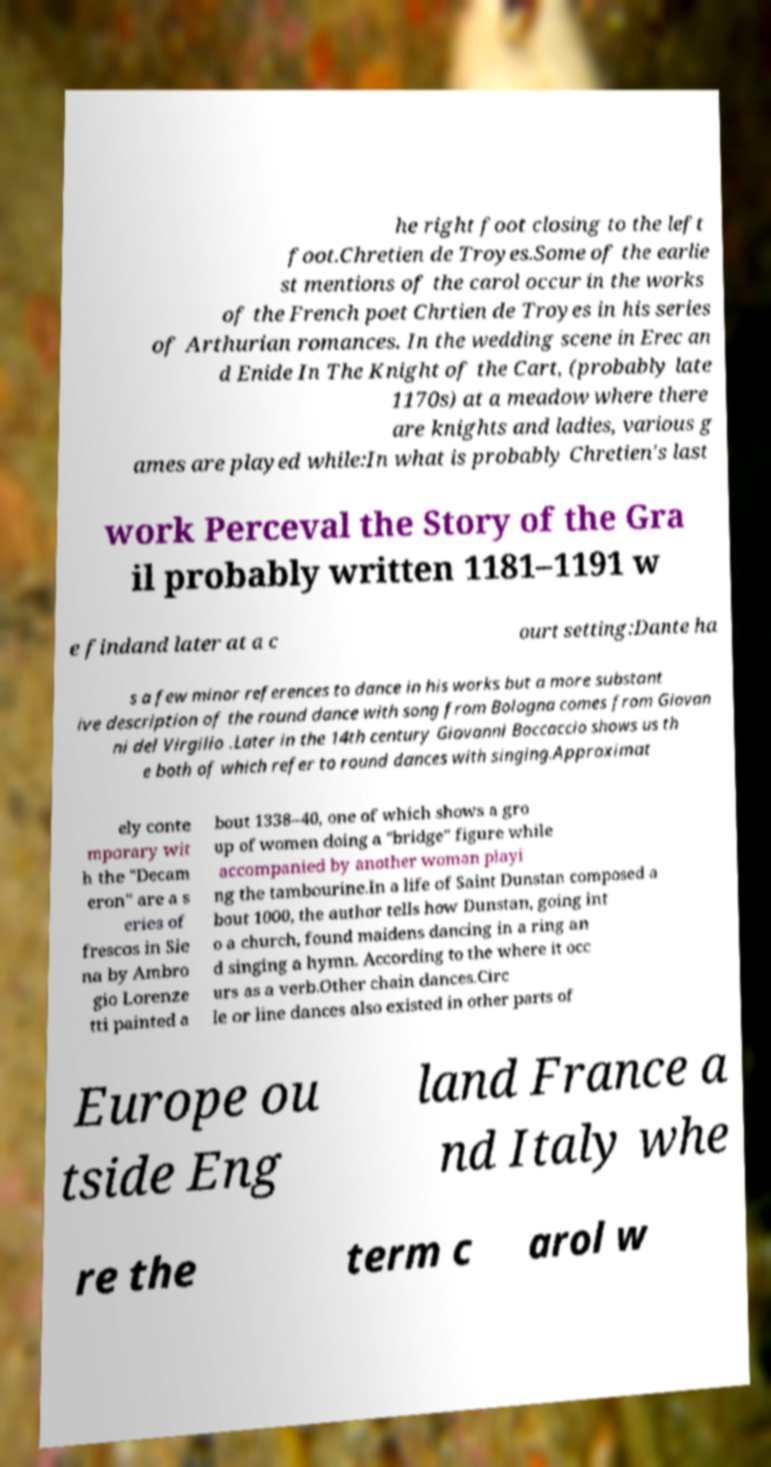Can you accurately transcribe the text from the provided image for me? he right foot closing to the left foot.Chretien de Troyes.Some of the earlie st mentions of the carol occur in the works of the French poet Chrtien de Troyes in his series of Arthurian romances. In the wedding scene in Erec an d Enide In The Knight of the Cart, (probably late 1170s) at a meadow where there are knights and ladies, various g ames are played while:In what is probably Chretien's last work Perceval the Story of the Gra il probably written 1181–1191 w e findand later at a c ourt setting:Dante ha s a few minor references to dance in his works but a more substant ive description of the round dance with song from Bologna comes from Giovan ni del Virgilio .Later in the 14th century Giovanni Boccaccio shows us th e both of which refer to round dances with singing.Approximat ely conte mporary wit h the "Decam eron" are a s eries of frescos in Sie na by Ambro gio Lorenze tti painted a bout 1338–40, one of which shows a gro up of women doing a "bridge" figure while accompanied by another woman playi ng the tambourine.In a life of Saint Dunstan composed a bout 1000, the author tells how Dunstan, going int o a church, found maidens dancing in a ring an d singing a hymn. According to the where it occ urs as a verb.Other chain dances.Circ le or line dances also existed in other parts of Europe ou tside Eng land France a nd Italy whe re the term c arol w 